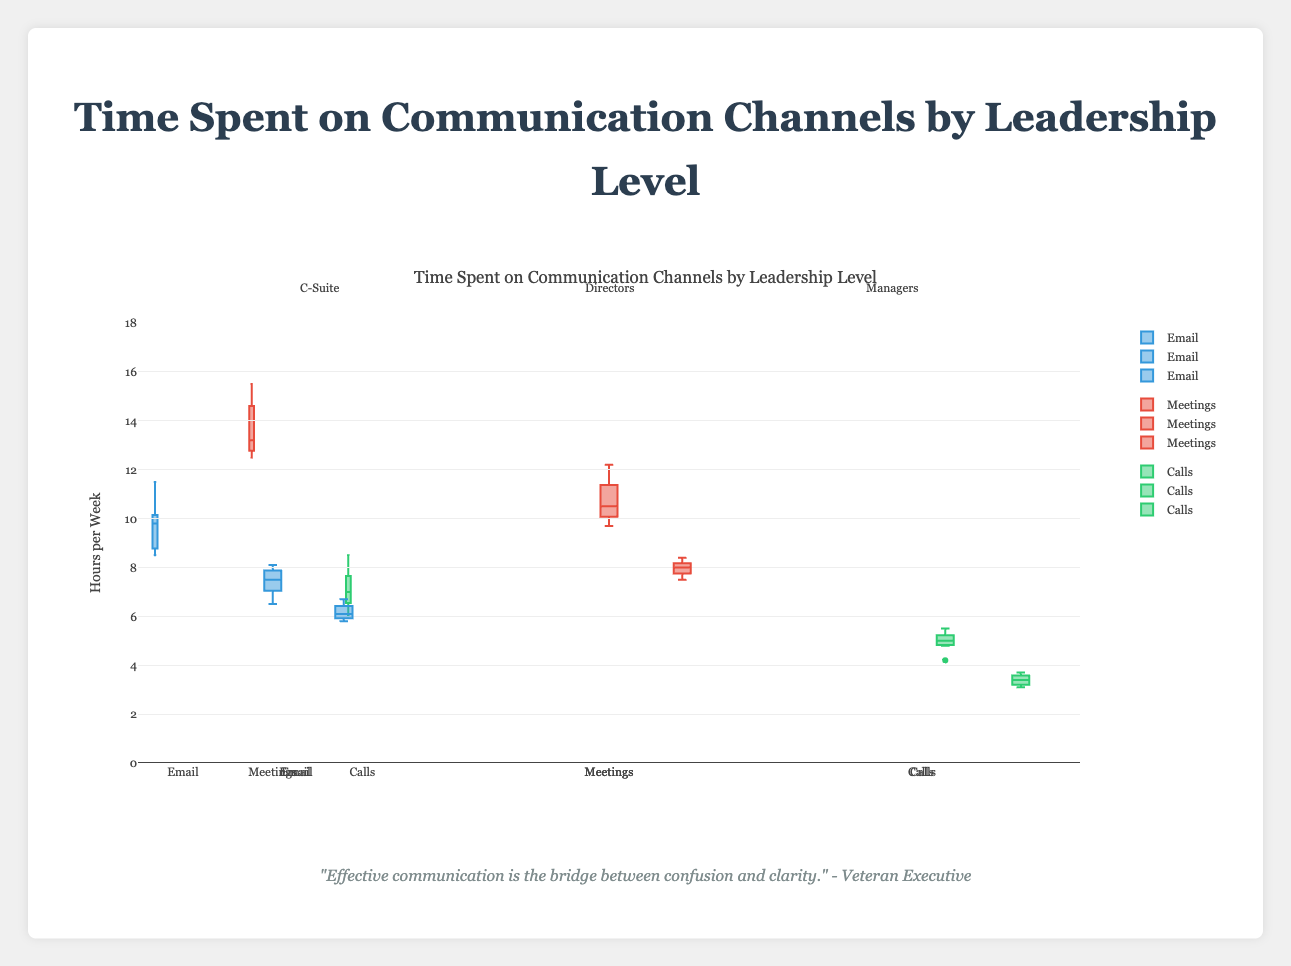What is the title of the figure? The title of the figure is displayed at the top and provides a summary of the content shown.
Answer: Time Spent on Communication Channels by Leadership Level What does the y-axis represent in this plot? The y-axis indicates the quantity being measured, as it is labeled to show what is being represented.
Answer: Hours per Week Which communication channel for the C-Suite has the highest median value? By looking at the middle line of the box plots for each communication channel in the C-Suite category, we can determine which one has the highest median.
Answer: Meetings How does the number of hours spent on meetings compare between C-Suite and Directors? Using the box plots for meetings under both C-Suite and Directors categories, we compare the median lines and the overall spread of values.
Answer: C-Suite Which leadership level spends the least time on calls? By comparing the box plots for calls across all leadership levels, we identify which one has the lowest median value.
Answer: Managers What is the interquartile range (IQR) for emails in the Managers category? IQR is calculated by subtracting the lower quartile (Q1) from the upper quartile (Q3) shown in the box plot for emails under Managers.
Answer: 6.7 - 6.0 = 0.7 Do Directors spend more time on meetings than emails? By comparing the medians of the box plots for meetings and emails under the Directors category, we infer the amount of time spent on each.
Answer: Yes Which communication channel has the widest spread of times in the C-Suite category? The spread of times is represented by the length of the box plot; we compare the lengths to determine which is the widest.
Answer: Meetings How does the variability in hours spent on calls compare between Directors and Managers? Variability is represented by the range and interquartile range of the box plots; comparing these for calls under Directors and Managers gives the answer.
Answer: More variability in Directors Given the box plots, which leadership level shows the greatest overall variability in the time spent on communication channels? By examining the range and IQR of box plots across all communication channels for each leadership level, we determine which exhibits the most variability.
Answer: C-Suite 